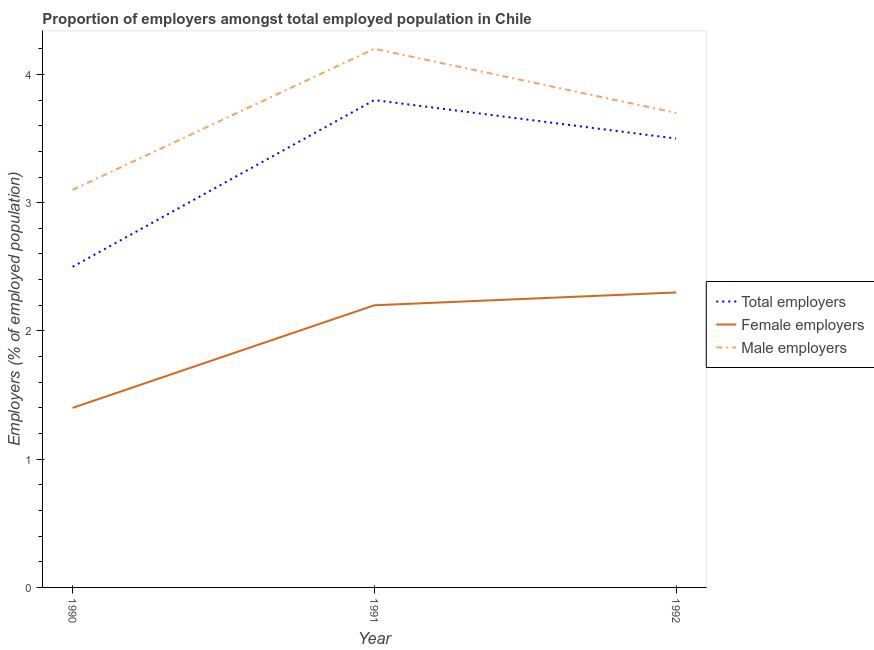Does the line corresponding to percentage of male employers intersect with the line corresponding to percentage of total employers?
Provide a short and direct response. No. What is the percentage of total employers in 1992?
Offer a terse response. 3.5. Across all years, what is the maximum percentage of female employers?
Provide a succinct answer. 2.3. Across all years, what is the minimum percentage of male employers?
Ensure brevity in your answer.  3.1. In which year was the percentage of female employers minimum?
Make the answer very short. 1990. What is the total percentage of female employers in the graph?
Offer a very short reply. 5.9. What is the difference between the percentage of male employers in 1990 and that in 1992?
Give a very brief answer. -0.6. What is the difference between the percentage of female employers in 1990 and the percentage of total employers in 1991?
Offer a terse response. -2.4. What is the average percentage of total employers per year?
Ensure brevity in your answer.  3.27. In the year 1992, what is the difference between the percentage of male employers and percentage of total employers?
Make the answer very short. 0.2. In how many years, is the percentage of male employers greater than 4 %?
Your response must be concise. 1. What is the ratio of the percentage of male employers in 1991 to that in 1992?
Your answer should be compact. 1.14. Is the percentage of male employers in 1990 less than that in 1991?
Provide a short and direct response. Yes. Is the difference between the percentage of female employers in 1990 and 1992 greater than the difference between the percentage of total employers in 1990 and 1992?
Your answer should be very brief. Yes. What is the difference between the highest and the second highest percentage of total employers?
Keep it short and to the point. 0.3. What is the difference between the highest and the lowest percentage of total employers?
Your response must be concise. 1.3. Is the sum of the percentage of female employers in 1990 and 1992 greater than the maximum percentage of male employers across all years?
Your response must be concise. No. Is it the case that in every year, the sum of the percentage of total employers and percentage of female employers is greater than the percentage of male employers?
Your answer should be very brief. Yes. Is the percentage of female employers strictly greater than the percentage of total employers over the years?
Your response must be concise. No. How many years are there in the graph?
Your answer should be compact. 3. What is the difference between two consecutive major ticks on the Y-axis?
Keep it short and to the point. 1. Are the values on the major ticks of Y-axis written in scientific E-notation?
Your answer should be compact. No. Does the graph contain any zero values?
Keep it short and to the point. No. Does the graph contain grids?
Keep it short and to the point. No. Where does the legend appear in the graph?
Offer a very short reply. Center right. How many legend labels are there?
Make the answer very short. 3. What is the title of the graph?
Offer a terse response. Proportion of employers amongst total employed population in Chile. Does "Secondary education" appear as one of the legend labels in the graph?
Ensure brevity in your answer.  No. What is the label or title of the X-axis?
Your answer should be very brief. Year. What is the label or title of the Y-axis?
Provide a succinct answer. Employers (% of employed population). What is the Employers (% of employed population) in Female employers in 1990?
Ensure brevity in your answer.  1.4. What is the Employers (% of employed population) in Male employers in 1990?
Ensure brevity in your answer.  3.1. What is the Employers (% of employed population) in Total employers in 1991?
Give a very brief answer. 3.8. What is the Employers (% of employed population) in Female employers in 1991?
Make the answer very short. 2.2. What is the Employers (% of employed population) in Male employers in 1991?
Ensure brevity in your answer.  4.2. What is the Employers (% of employed population) of Total employers in 1992?
Offer a very short reply. 3.5. What is the Employers (% of employed population) of Female employers in 1992?
Your response must be concise. 2.3. What is the Employers (% of employed population) of Male employers in 1992?
Keep it short and to the point. 3.7. Across all years, what is the maximum Employers (% of employed population) of Total employers?
Make the answer very short. 3.8. Across all years, what is the maximum Employers (% of employed population) of Female employers?
Give a very brief answer. 2.3. Across all years, what is the maximum Employers (% of employed population) in Male employers?
Offer a very short reply. 4.2. Across all years, what is the minimum Employers (% of employed population) of Female employers?
Ensure brevity in your answer.  1.4. Across all years, what is the minimum Employers (% of employed population) of Male employers?
Your answer should be compact. 3.1. What is the total Employers (% of employed population) of Total employers in the graph?
Offer a very short reply. 9.8. What is the difference between the Employers (% of employed population) of Male employers in 1990 and that in 1991?
Provide a short and direct response. -1.1. What is the difference between the Employers (% of employed population) of Male employers in 1990 and that in 1992?
Ensure brevity in your answer.  -0.6. What is the difference between the Employers (% of employed population) in Male employers in 1991 and that in 1992?
Your response must be concise. 0.5. What is the difference between the Employers (% of employed population) of Female employers in 1990 and the Employers (% of employed population) of Male employers in 1992?
Provide a succinct answer. -2.3. What is the average Employers (% of employed population) in Total employers per year?
Provide a short and direct response. 3.27. What is the average Employers (% of employed population) in Female employers per year?
Your answer should be compact. 1.97. What is the average Employers (% of employed population) of Male employers per year?
Provide a succinct answer. 3.67. In the year 1990, what is the difference between the Employers (% of employed population) in Total employers and Employers (% of employed population) in Female employers?
Ensure brevity in your answer.  1.1. In the year 1990, what is the difference between the Employers (% of employed population) of Total employers and Employers (% of employed population) of Male employers?
Offer a terse response. -0.6. In the year 1991, what is the difference between the Employers (% of employed population) in Total employers and Employers (% of employed population) in Male employers?
Provide a succinct answer. -0.4. In the year 1991, what is the difference between the Employers (% of employed population) in Female employers and Employers (% of employed population) in Male employers?
Provide a short and direct response. -2. What is the ratio of the Employers (% of employed population) of Total employers in 1990 to that in 1991?
Offer a terse response. 0.66. What is the ratio of the Employers (% of employed population) of Female employers in 1990 to that in 1991?
Make the answer very short. 0.64. What is the ratio of the Employers (% of employed population) of Male employers in 1990 to that in 1991?
Give a very brief answer. 0.74. What is the ratio of the Employers (% of employed population) of Total employers in 1990 to that in 1992?
Offer a terse response. 0.71. What is the ratio of the Employers (% of employed population) of Female employers in 1990 to that in 1992?
Your response must be concise. 0.61. What is the ratio of the Employers (% of employed population) in Male employers in 1990 to that in 1992?
Your answer should be very brief. 0.84. What is the ratio of the Employers (% of employed population) of Total employers in 1991 to that in 1992?
Your response must be concise. 1.09. What is the ratio of the Employers (% of employed population) in Female employers in 1991 to that in 1992?
Ensure brevity in your answer.  0.96. What is the ratio of the Employers (% of employed population) in Male employers in 1991 to that in 1992?
Provide a succinct answer. 1.14. What is the difference between the highest and the second highest Employers (% of employed population) in Male employers?
Provide a short and direct response. 0.5. 